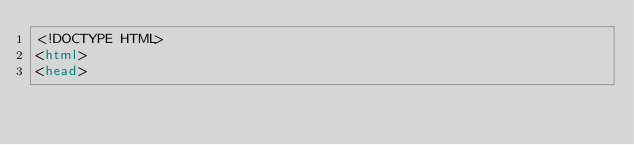Convert code to text. <code><loc_0><loc_0><loc_500><loc_500><_HTML_><!DOCTYPE HTML>
<html>
<head></code> 